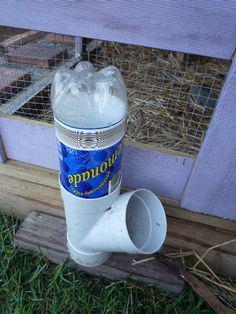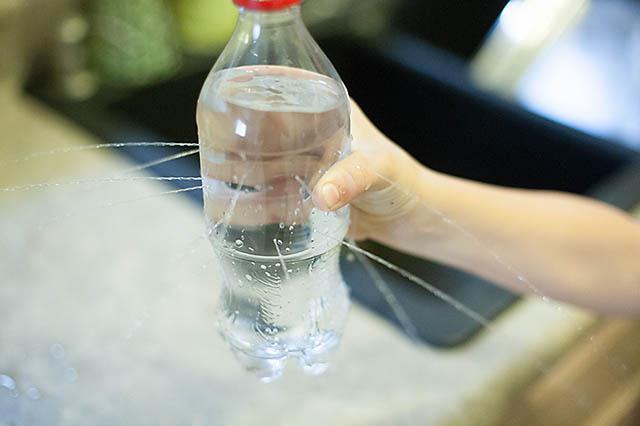The first image is the image on the left, the second image is the image on the right. Analyze the images presented: Is the assertion "At least one plastic bottle has been cut in half." valid? Answer yes or no. No. The first image is the image on the left, the second image is the image on the right. Evaluate the accuracy of this statement regarding the images: "Human hands are visible holding soda bottles in at least one image.". Is it true? Answer yes or no. Yes. 